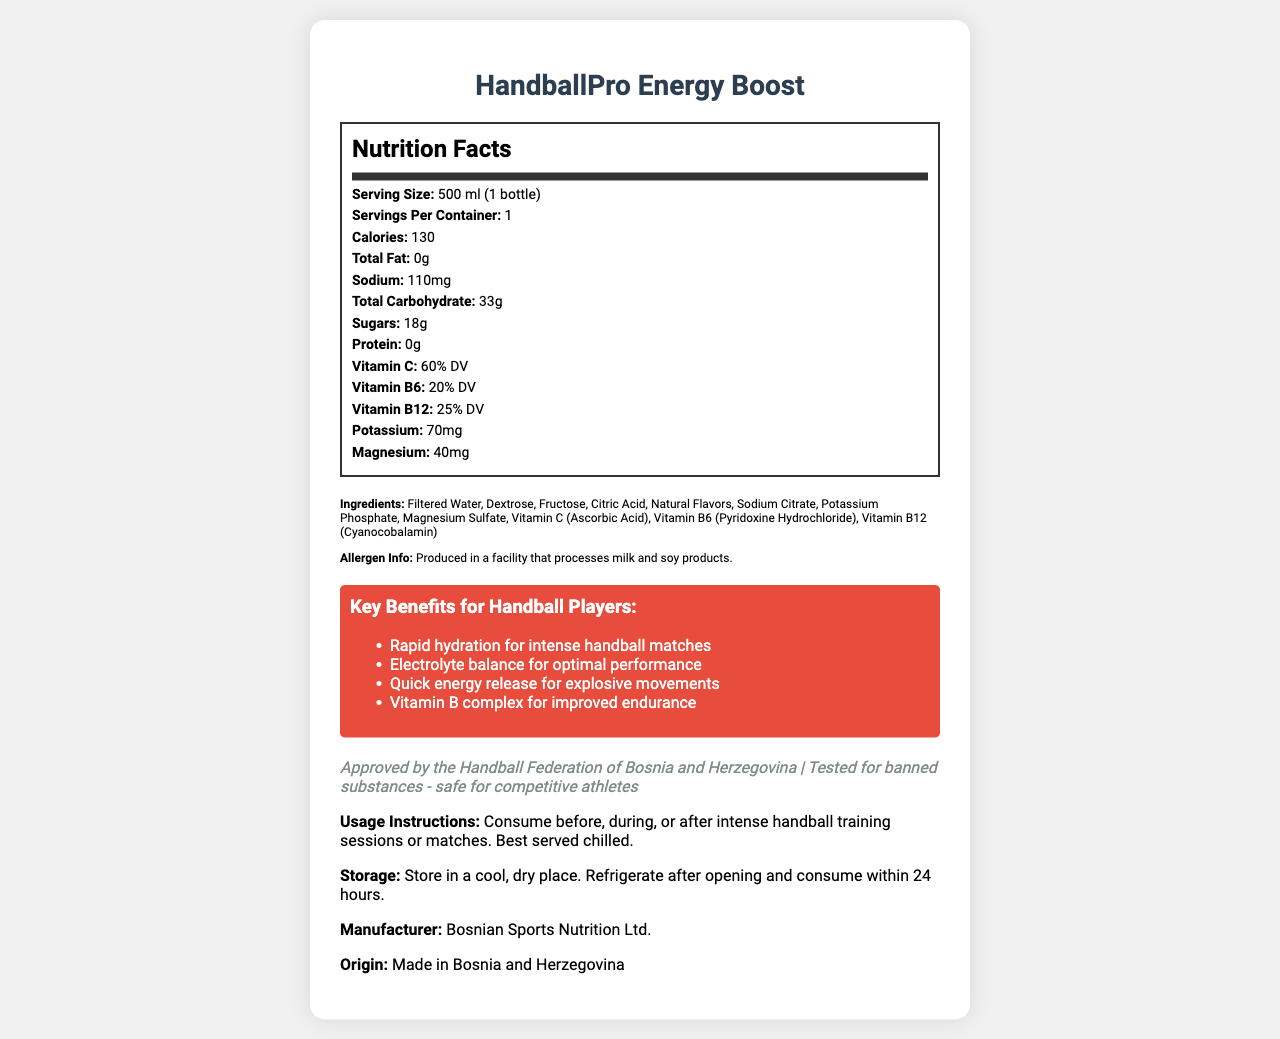What is the serving size of HandballPro Energy Boost? The serving size of the product is mentioned as "500 ml (1 bottle)" under the Nutrition Facts.
Answer: 500 ml (1 bottle) How many calories are in one bottle of HandballPro Energy Boost? The document states that "Calories: 130" in the Nutrition Facts section.
Answer: 130 What percentage of Vitamin C is provided per serving? The Nutrition Facts label indicates "Vitamin C: 60% DV".
Answer: 60% DV List two electrolytes found in HandballPro Energy Boost. The Nutrition Facts indicate "Potassium: 70mg" and "Magnesium: 40mg".
Answer: Potassium and Magnesium Which vitamins are included in HandballPro Energy Boost? The document lists these vitamins in the Nutrition Facts section.
Answer: Vitamin C, Vitamin B6, Vitamin B12 How much total carbohydrate is in one serving of HandballPro Energy Boost? The Nutrition Facts section mentions "Total Carbohydrate: 33g".
Answer: 33g Who is the manufacturer of HandballPro Energy Boost? The end of the document states "Manufacturer: Bosnian Sports Nutrition Ltd."
Answer: Bosnian Sports Nutrition Ltd. What is the product origin of HandballPro Energy Boost? The document states "Origin: Made in Bosnia and Herzegovina."
Answer: Made in Bosnia and Herzegovina What is the main purpose of consuming HandballPro Energy Boost according to the document? The document emphasizes its key benefits and usage instructions for handball players.
Answer: For hydration, electrolyte balance, quick energy release, and improved endurance during handball training sessions or matches What is the sodium content per serving in HandballPro Energy Boost? The Nutrition Facts section indicates "Sodium: 110mg".
Answer: 110mg When is the best time to consume HandballPro Energy Boost according to the product’s usage instructions? The usage instructions state, "Consume before, during, or after intense handball training sessions or matches."
Answer: Before, during, or after intense handball training sessions or matches Which of the following is *not* an ingredient in HandballPro Energy Boost? A. Fructose B. Ascorbic Acid C. High Fructose Corn Syrup D. Pyridoxine Hydrochloride This ingredient is not listed among the ingredients, while the others are included.
Answer: C. High Fructose Corn Syrup What is the main color of the benefits section in the document? A. Blue B. Green C. Red D. Yellow The document mentions that the benefits section is a “background color of #e74c3c,” which is red.
Answer: C. Red Is HandballPro Energy Boost suitable for consumption by competitive athletes? The document states that it is "Tested for banned substances - safe for competitive athletes."
Answer: Yes Summarize the document. The document presents a detailed description of the product’s nutritional information, ingredients, benefits, certifications, and usage instructions, targeted at handball players aiming for optimal performance.
Answer: HandballPro Energy Boost is a sports drink designed for handball players, featuring vitamins, electrolytes, and easy-to-digest carbohydrates to enhance performance. Approved by relevant sports authority, it offers hydration, quick energy release, and improved endurance. The drink includes a Nutrition Facts section, ingredients list, usage instructions, and storage guidelines. What is the recommended storage instruction for HandballPro Energy Boost after opening? The document advises to "Refrigerate after opening and consume within 24 hours."
Answer: Refrigerate after opening and consume within 24 hours How much sugar does one serving of HandballPro Energy Boost have? The Nutrition Facts section lists "Sugars: 18g".
Answer: 18g What facility information is provided regarding allergens? The document states this under allergen info.
Answer: Produced in a facility that processes milk and soy products. Does the document provide the exact number of servings in each container? It states "Servings Per Container: 1."
Answer: Yes Is there information about the drink’s impact on hydration? The document highlights "Rapid hydration for intense handball matches" as a key benefit.
Answer: Yes 